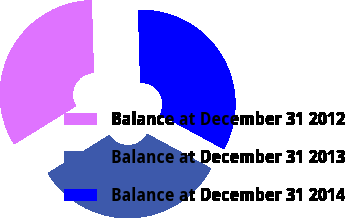Convert chart. <chart><loc_0><loc_0><loc_500><loc_500><pie_chart><fcel>Balance at December 31 2012<fcel>Balance at December 31 2013<fcel>Balance at December 31 2014<nl><fcel>33.35%<fcel>33.32%<fcel>33.33%<nl></chart> 